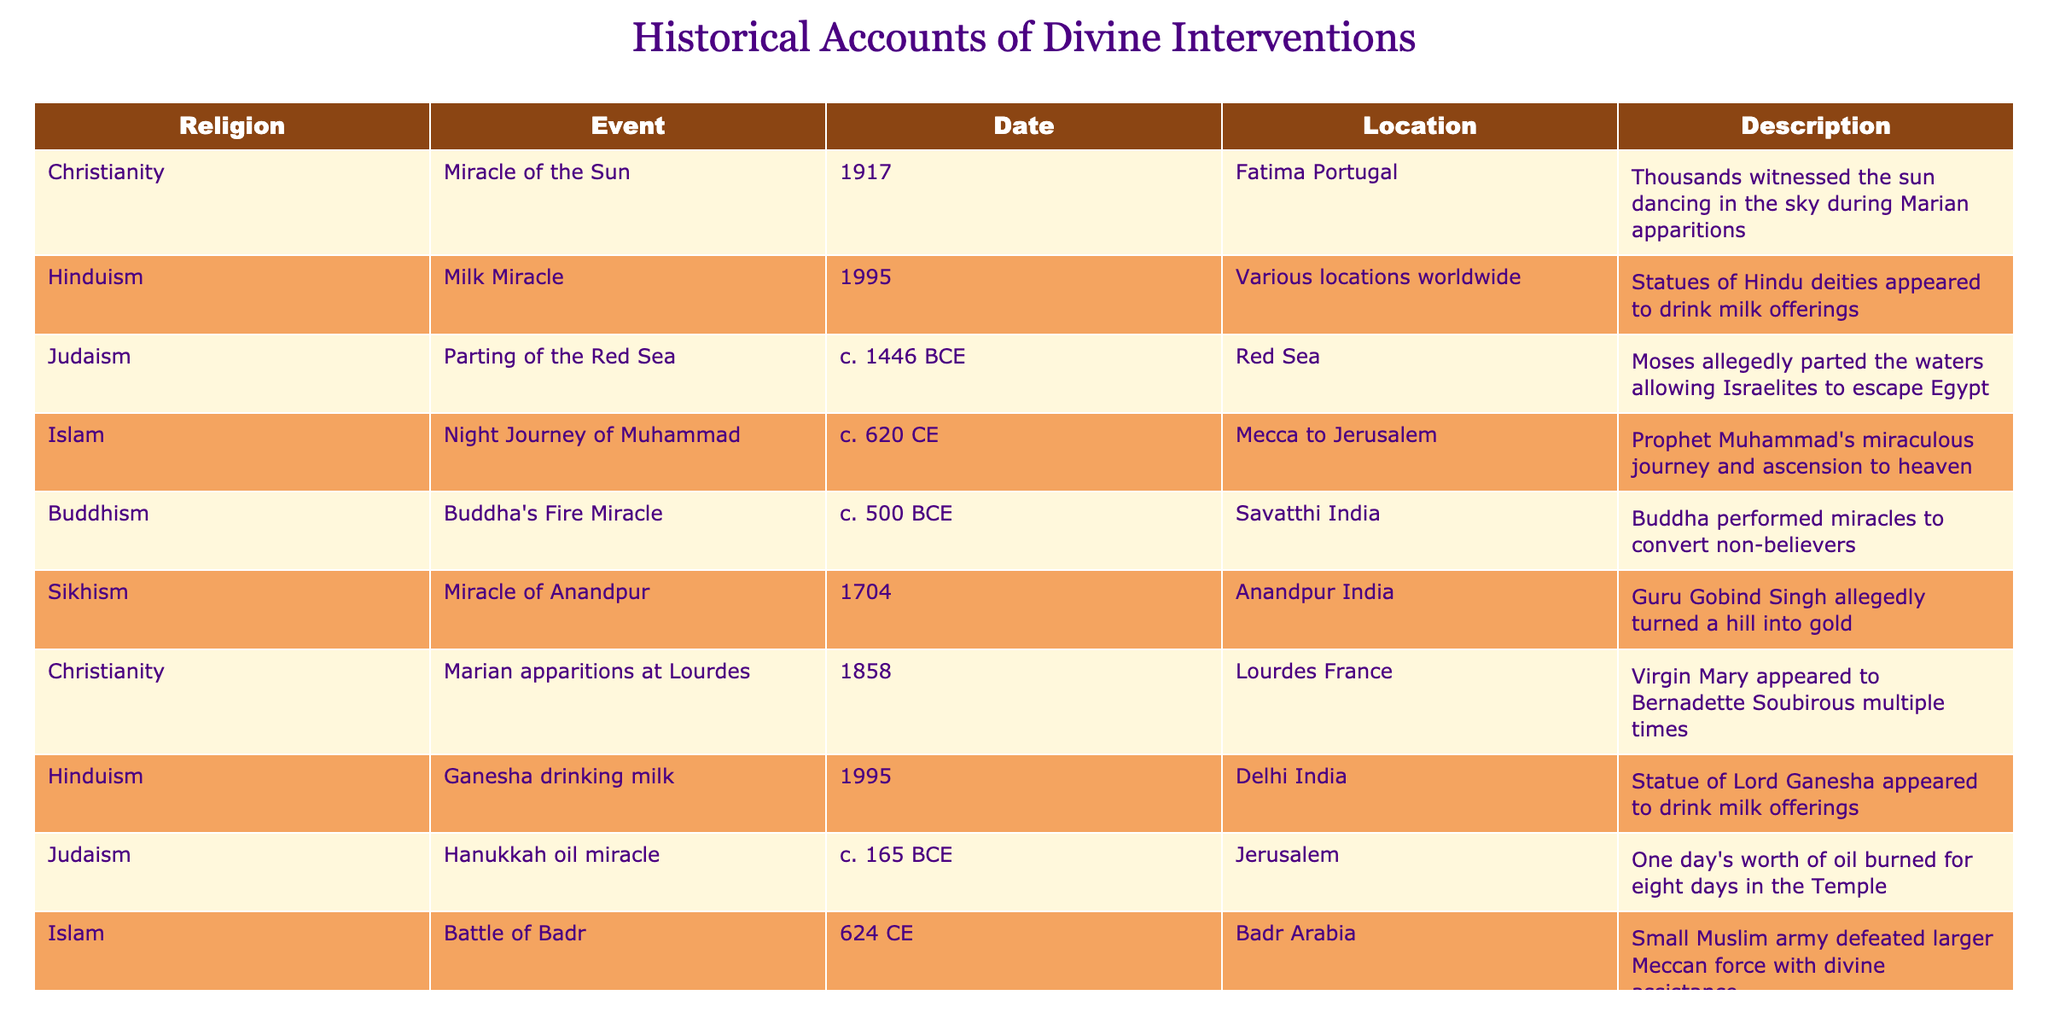What is the oldest event listed in the table? The table lists various events, and to find the oldest, we can review the "Date" column. The event with the date "c. 1446 BCE," which is the Parting of the Red Sea in Judaism, is the earliest recorded event.
Answer: Parting of the Red Sea Which religion has an event taking place in 1995? Two events in the table occur in 1995: the Milk Miracle in Hinduism and Ganesha drinking milk in Hinduism. Thus, Hinduism is the only religion with events taking place in that year.
Answer: Hinduism Are there any events that took place in Jerusalem? A look at the "Location" column shows that two events—the Hanukkah oil miracle and the Night Journey of Muhammad—occur in Jerusalem, confirming that there are indeed events in this location.
Answer: Yes How many miracles are attributed to Christianity in the table? The table lists three events related to Christianity: Miracle of the Sun, Marian apparitions at Lourdes, and the Parthian of the Red Sea. Therefore, the count of Christian miracles is three.
Answer: Three Which event involved a miraculous defeat of a larger army? The Battle of Badr in Islam describes a small Muslim army defeating a larger Meccan force with divine assistance, which clearly indicates this event's miraculous nature.
Answer: Battle of Badr How many events listed occurred outside of Asia? By examining the "Location" column, the Miracle of the Sun (Portugal), Marian apparitions at Lourdes (France), and the Battle of Badr (Arabia) are the only events not in Asia. Three events thus occurred outside Asia.
Answer: Three Which religious event is the most recent on the list? The most recent date listed is 1995, which corresponds to two events in Hinduism: the Milk Miracle and Ganesha drinking milk. Hence, both are the most recent events in the table.
Answer: 1995 In total, how many divine interventions are recorded for Islam? There are two events in the table associated with Islam: the Night Journey of Muhammad and the Battle of Badr. Adding these gives a total of two divine interventions recorded for Islam.
Answer: Two What is the significance of the date range covered in this table? The events range from around 1446 BCE to 1995, spanning over 3,400 years. This range shows how various religions, across time, have reported accounts of divine intervention, pointing to a long-standing theological interest in such events throughout history.
Answer: Over 3,400 years 